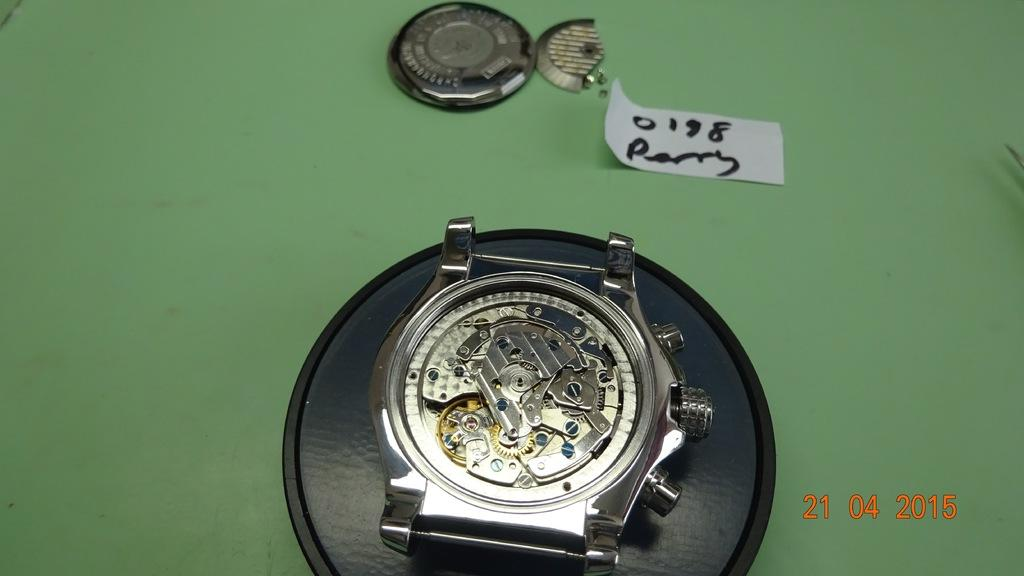Provide a one-sentence caption for the provided image. A watch with the back taken off with the date stamp of april 21st 2015/. 